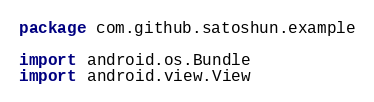<code> <loc_0><loc_0><loc_500><loc_500><_Kotlin_>package com.github.satoshun.example

import android.os.Bundle
import android.view.View</code> 